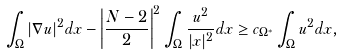Convert formula to latex. <formula><loc_0><loc_0><loc_500><loc_500>\int _ { \Omega } | \nabla u | ^ { 2 } d x - \left | \frac { N - 2 } { 2 } \right | ^ { 2 } \int _ { \Omega } \frac { u ^ { 2 } } { | x | ^ { 2 } } d x \geq c _ { \Omega ^ { * } } \int _ { \Omega } u ^ { 2 } d x ,</formula> 